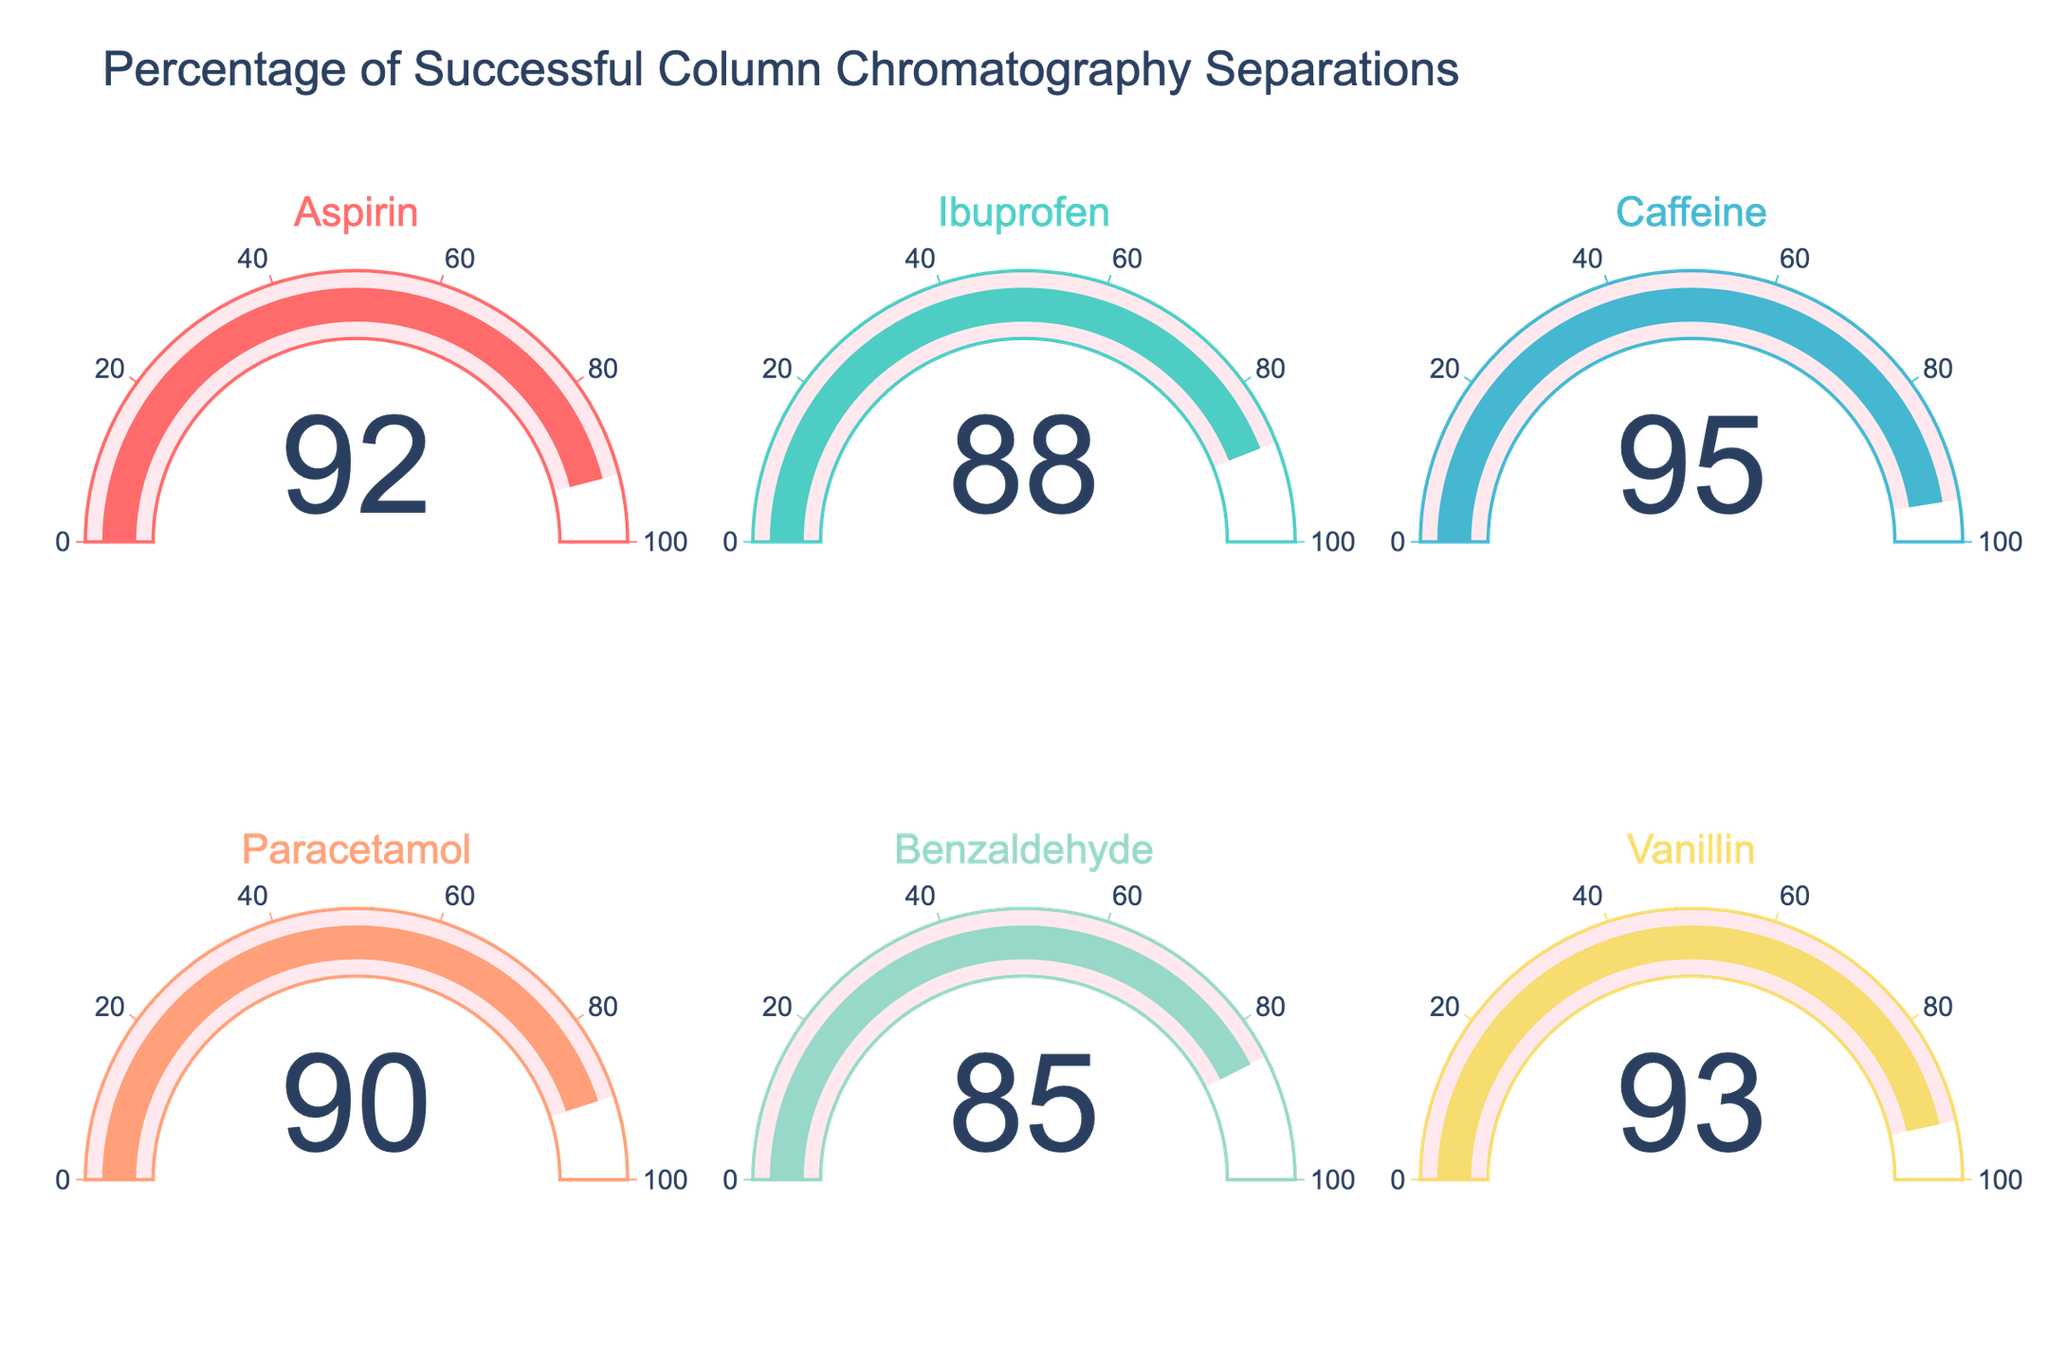what is the title of the chart? The title of the chart indicates the purpose of the plot. In this case, it provides context for understanding the data being presented, which is the success rate of separations for different compounds. It is prominently seen at the top of the figure.
Answer: Percentage of Successful Column Chromatography Separations How many compounds are included in the figure? By counting the number of distinct gauges displayed for each success rate, we can determine the number of compounds.
Answer: 6 Which compound has the highest success rate? By visually inspecting each gauge, we look for the one with the highest value presented in the number format within the gauge.
Answer: Caffeine Which compound has the lowest success rate? Similar to finding the highest, we inspect each gauge for the lowest number displayed.
Answer: Benzaldehyde What is the average success rate of all the compounds? Add all success rates and then divide by the number of compounds: (92 + 88 + 95 + 90 + 85 + 93)/6. This will give the average.
Answer: 90.5 What's the success rate difference between Aspirin and Ibuprofen? Subtract the success rate of Ibuprofen from that of Aspirin: 92 - 88.
Answer: 4 How much higher is the success rate of Vanillin compared to Benzaldehyde? Subtract the success rate of Benzaldehyde from Vanillin: 93 - 85.
Answer: 8 Are there any compounds with the same success rate? Visually compare the success rates displayed within the gauges to see if any two compounds have the same numerical value.
Answer: No Is the success rate of Paracetamol greater than the average success rate of all compounds? Compute the average (90.5), then compare it to Paracetamol’s success rate: 90. Since 90 < 90.5, it is not greater.
Answer: No If you were to improve the success rate of Benzaldehyde to at least 90%, how much of an increase would that be? Subtract the current success rate of Benzaldehyde from the target success rate: 90 - 85.
Answer: 5 